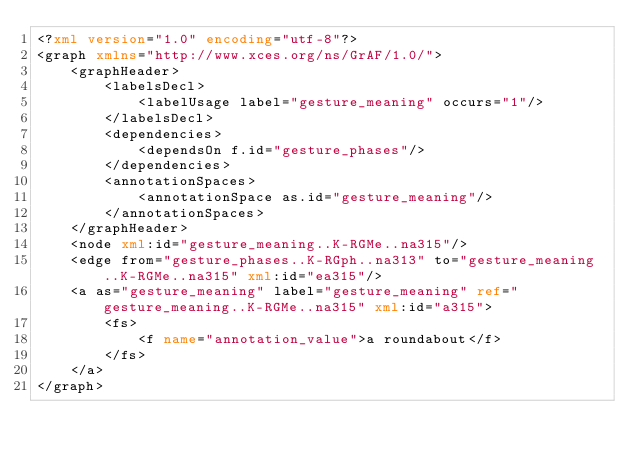Convert code to text. <code><loc_0><loc_0><loc_500><loc_500><_XML_><?xml version="1.0" encoding="utf-8"?>
<graph xmlns="http://www.xces.org/ns/GrAF/1.0/">
	<graphHeader>
		<labelsDecl>
			<labelUsage label="gesture_meaning" occurs="1"/>
		</labelsDecl>
		<dependencies>
			<dependsOn f.id="gesture_phases"/>
		</dependencies>
		<annotationSpaces>
			<annotationSpace as.id="gesture_meaning"/>
		</annotationSpaces>
	</graphHeader>
	<node xml:id="gesture_meaning..K-RGMe..na315"/>
	<edge from="gesture_phases..K-RGph..na313" to="gesture_meaning..K-RGMe..na315" xml:id="ea315"/>
	<a as="gesture_meaning" label="gesture_meaning" ref="gesture_meaning..K-RGMe..na315" xml:id="a315">
		<fs>
			<f name="annotation_value">a roundabout</f>
		</fs>
	</a>
</graph>
</code> 